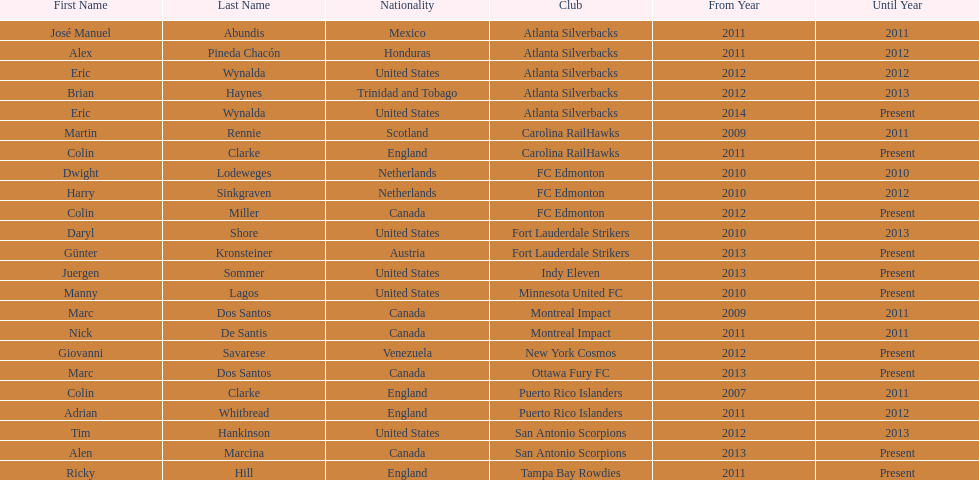What name is listed at the top? José Manuel Abundis. 